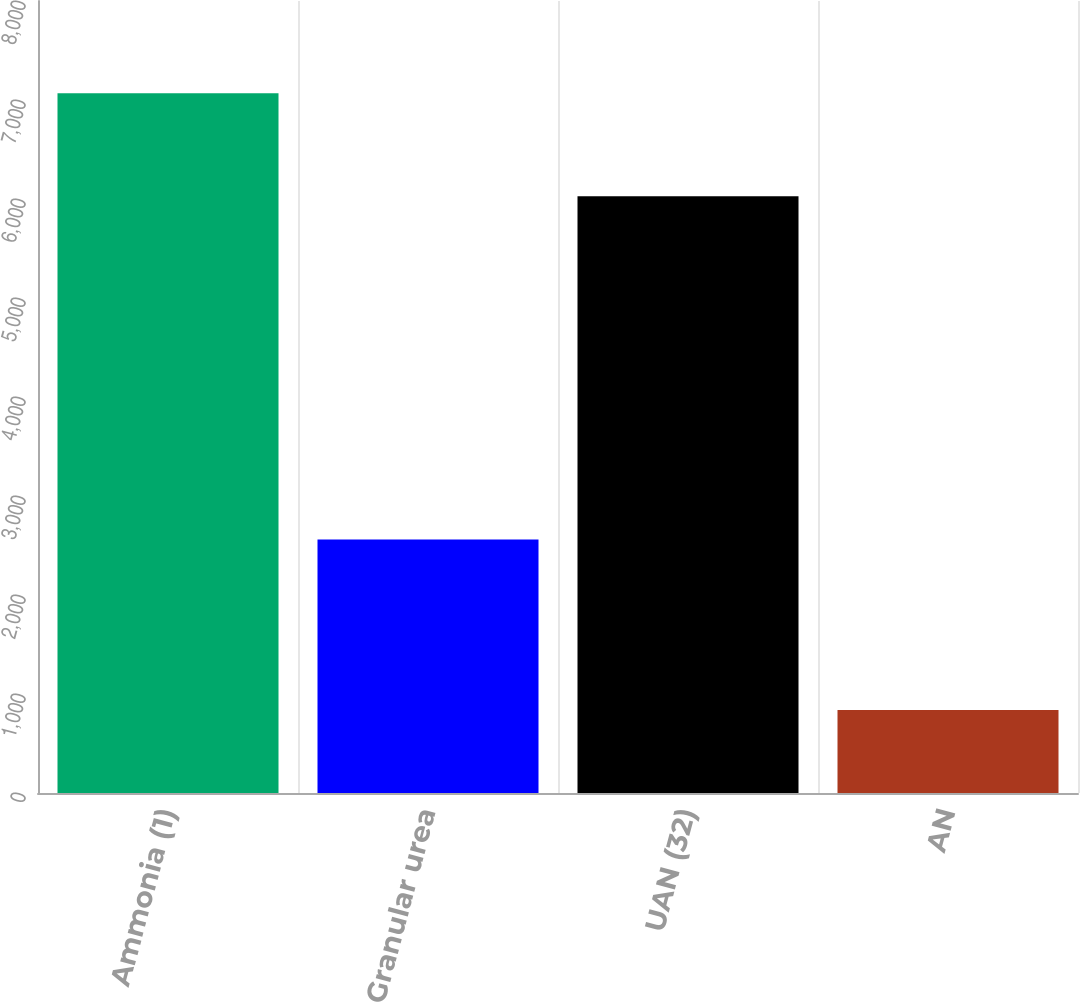Convert chart. <chart><loc_0><loc_0><loc_500><loc_500><bar_chart><fcel>Ammonia (1)<fcel>Granular urea<fcel>UAN (32)<fcel>AN<nl><fcel>7067<fcel>2560<fcel>6027<fcel>839<nl></chart> 